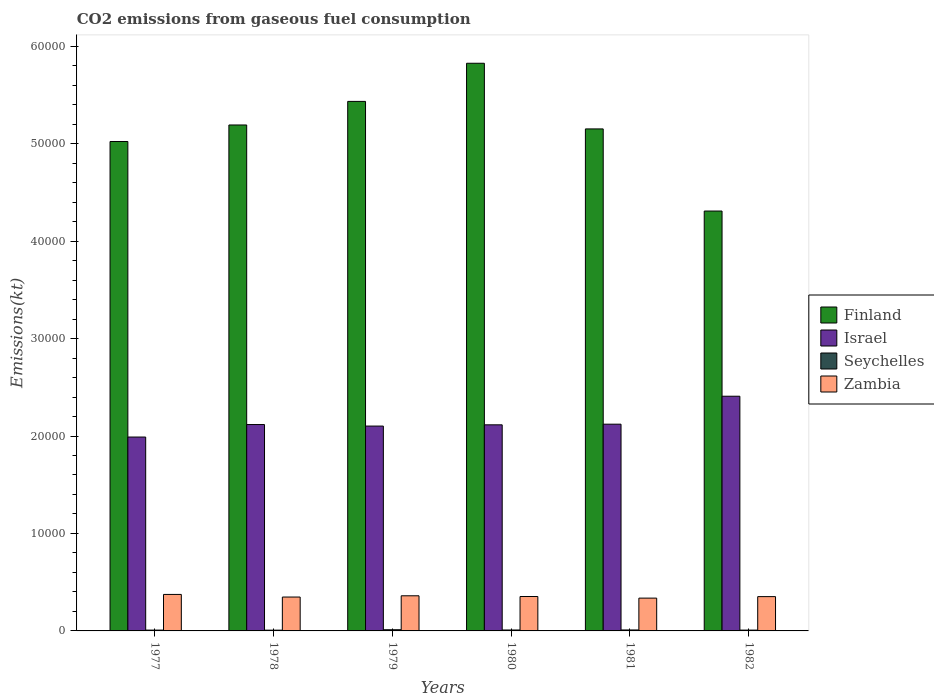Are the number of bars per tick equal to the number of legend labels?
Offer a very short reply. Yes. Are the number of bars on each tick of the X-axis equal?
Offer a terse response. Yes. How many bars are there on the 5th tick from the left?
Keep it short and to the point. 4. How many bars are there on the 4th tick from the right?
Provide a succinct answer. 4. What is the amount of CO2 emitted in Seychelles in 1980?
Provide a short and direct response. 95.34. Across all years, what is the maximum amount of CO2 emitted in Seychelles?
Give a very brief answer. 121.01. Across all years, what is the minimum amount of CO2 emitted in Israel?
Give a very brief answer. 1.99e+04. What is the total amount of CO2 emitted in Seychelles in the graph?
Offer a terse response. 561.05. What is the difference between the amount of CO2 emitted in Seychelles in 1978 and that in 1982?
Provide a succinct answer. -7.33. What is the difference between the amount of CO2 emitted in Finland in 1981 and the amount of CO2 emitted in Zambia in 1982?
Your response must be concise. 4.80e+04. What is the average amount of CO2 emitted in Seychelles per year?
Your response must be concise. 93.51. In the year 1979, what is the difference between the amount of CO2 emitted in Finland and amount of CO2 emitted in Seychelles?
Provide a succinct answer. 5.42e+04. What is the ratio of the amount of CO2 emitted in Zambia in 1979 to that in 1981?
Your answer should be very brief. 1.07. Is the difference between the amount of CO2 emitted in Finland in 1977 and 1980 greater than the difference between the amount of CO2 emitted in Seychelles in 1977 and 1980?
Keep it short and to the point. No. What is the difference between the highest and the second highest amount of CO2 emitted in Zambia?
Ensure brevity in your answer.  139.35. What is the difference between the highest and the lowest amount of CO2 emitted in Israel?
Provide a succinct answer. 4187.71. In how many years, is the amount of CO2 emitted in Israel greater than the average amount of CO2 emitted in Israel taken over all years?
Ensure brevity in your answer.  1. Is the sum of the amount of CO2 emitted in Israel in 1980 and 1981 greater than the maximum amount of CO2 emitted in Zambia across all years?
Offer a terse response. Yes. Is it the case that in every year, the sum of the amount of CO2 emitted in Zambia and amount of CO2 emitted in Finland is greater than the sum of amount of CO2 emitted in Seychelles and amount of CO2 emitted in Israel?
Ensure brevity in your answer.  Yes. What does the 2nd bar from the right in 1982 represents?
Ensure brevity in your answer.  Seychelles. How many bars are there?
Keep it short and to the point. 24. Are all the bars in the graph horizontal?
Provide a succinct answer. No. How many years are there in the graph?
Give a very brief answer. 6. Are the values on the major ticks of Y-axis written in scientific E-notation?
Ensure brevity in your answer.  No. Does the graph contain any zero values?
Your answer should be very brief. No. Does the graph contain grids?
Offer a terse response. No. What is the title of the graph?
Offer a terse response. CO2 emissions from gaseous fuel consumption. Does "Paraguay" appear as one of the legend labels in the graph?
Offer a very short reply. No. What is the label or title of the Y-axis?
Ensure brevity in your answer.  Emissions(kt). What is the Emissions(kt) of Finland in 1977?
Offer a terse response. 5.02e+04. What is the Emissions(kt) of Israel in 1977?
Your answer should be compact. 1.99e+04. What is the Emissions(kt) of Seychelles in 1977?
Your answer should be compact. 84.34. What is the Emissions(kt) of Zambia in 1977?
Provide a short and direct response. 3744.01. What is the Emissions(kt) in Finland in 1978?
Give a very brief answer. 5.19e+04. What is the Emissions(kt) in Israel in 1978?
Provide a short and direct response. 2.12e+04. What is the Emissions(kt) in Seychelles in 1978?
Your response must be concise. 77.01. What is the Emissions(kt) in Zambia in 1978?
Ensure brevity in your answer.  3476.32. What is the Emissions(kt) of Finland in 1979?
Your answer should be very brief. 5.43e+04. What is the Emissions(kt) of Israel in 1979?
Keep it short and to the point. 2.10e+04. What is the Emissions(kt) in Seychelles in 1979?
Offer a very short reply. 121.01. What is the Emissions(kt) of Zambia in 1979?
Give a very brief answer. 3604.66. What is the Emissions(kt) in Finland in 1980?
Give a very brief answer. 5.82e+04. What is the Emissions(kt) in Israel in 1980?
Your answer should be compact. 2.11e+04. What is the Emissions(kt) of Seychelles in 1980?
Offer a terse response. 95.34. What is the Emissions(kt) in Zambia in 1980?
Ensure brevity in your answer.  3531.32. What is the Emissions(kt) of Finland in 1981?
Your answer should be very brief. 5.15e+04. What is the Emissions(kt) of Israel in 1981?
Provide a succinct answer. 2.12e+04. What is the Emissions(kt) in Seychelles in 1981?
Ensure brevity in your answer.  99.01. What is the Emissions(kt) of Zambia in 1981?
Give a very brief answer. 3366.31. What is the Emissions(kt) of Finland in 1982?
Your answer should be compact. 4.31e+04. What is the Emissions(kt) of Israel in 1982?
Provide a short and direct response. 2.41e+04. What is the Emissions(kt) in Seychelles in 1982?
Offer a terse response. 84.34. What is the Emissions(kt) in Zambia in 1982?
Ensure brevity in your answer.  3520.32. Across all years, what is the maximum Emissions(kt) of Finland?
Your answer should be very brief. 5.82e+04. Across all years, what is the maximum Emissions(kt) of Israel?
Your answer should be compact. 2.41e+04. Across all years, what is the maximum Emissions(kt) of Seychelles?
Keep it short and to the point. 121.01. Across all years, what is the maximum Emissions(kt) in Zambia?
Make the answer very short. 3744.01. Across all years, what is the minimum Emissions(kt) of Finland?
Your answer should be very brief. 4.31e+04. Across all years, what is the minimum Emissions(kt) in Israel?
Your answer should be very brief. 1.99e+04. Across all years, what is the minimum Emissions(kt) of Seychelles?
Offer a very short reply. 77.01. Across all years, what is the minimum Emissions(kt) of Zambia?
Your response must be concise. 3366.31. What is the total Emissions(kt) in Finland in the graph?
Provide a succinct answer. 3.09e+05. What is the total Emissions(kt) in Israel in the graph?
Make the answer very short. 1.29e+05. What is the total Emissions(kt) in Seychelles in the graph?
Offer a terse response. 561.05. What is the total Emissions(kt) of Zambia in the graph?
Keep it short and to the point. 2.12e+04. What is the difference between the Emissions(kt) in Finland in 1977 and that in 1978?
Your response must be concise. -1694.15. What is the difference between the Emissions(kt) of Israel in 1977 and that in 1978?
Provide a short and direct response. -1283.45. What is the difference between the Emissions(kt) of Seychelles in 1977 and that in 1978?
Provide a short and direct response. 7.33. What is the difference between the Emissions(kt) in Zambia in 1977 and that in 1978?
Give a very brief answer. 267.69. What is the difference between the Emissions(kt) in Finland in 1977 and that in 1979?
Your answer should be very brief. -4114.37. What is the difference between the Emissions(kt) in Israel in 1977 and that in 1979?
Ensure brevity in your answer.  -1125.77. What is the difference between the Emissions(kt) of Seychelles in 1977 and that in 1979?
Provide a short and direct response. -36.67. What is the difference between the Emissions(kt) of Zambia in 1977 and that in 1979?
Provide a succinct answer. 139.35. What is the difference between the Emissions(kt) in Finland in 1977 and that in 1980?
Provide a short and direct response. -8027.06. What is the difference between the Emissions(kt) in Israel in 1977 and that in 1980?
Keep it short and to the point. -1254.11. What is the difference between the Emissions(kt) in Seychelles in 1977 and that in 1980?
Your response must be concise. -11. What is the difference between the Emissions(kt) in Zambia in 1977 and that in 1980?
Provide a succinct answer. 212.69. What is the difference between the Emissions(kt) of Finland in 1977 and that in 1981?
Provide a short and direct response. -1290.78. What is the difference between the Emissions(kt) of Israel in 1977 and that in 1981?
Provide a short and direct response. -1320.12. What is the difference between the Emissions(kt) of Seychelles in 1977 and that in 1981?
Your response must be concise. -14.67. What is the difference between the Emissions(kt) of Zambia in 1977 and that in 1981?
Your answer should be compact. 377.7. What is the difference between the Emissions(kt) in Finland in 1977 and that in 1982?
Give a very brief answer. 7135.98. What is the difference between the Emissions(kt) in Israel in 1977 and that in 1982?
Provide a succinct answer. -4187.71. What is the difference between the Emissions(kt) of Seychelles in 1977 and that in 1982?
Your response must be concise. 0. What is the difference between the Emissions(kt) in Zambia in 1977 and that in 1982?
Give a very brief answer. 223.69. What is the difference between the Emissions(kt) in Finland in 1978 and that in 1979?
Your answer should be compact. -2420.22. What is the difference between the Emissions(kt) of Israel in 1978 and that in 1979?
Keep it short and to the point. 157.68. What is the difference between the Emissions(kt) of Seychelles in 1978 and that in 1979?
Provide a succinct answer. -44. What is the difference between the Emissions(kt) of Zambia in 1978 and that in 1979?
Provide a short and direct response. -128.34. What is the difference between the Emissions(kt) of Finland in 1978 and that in 1980?
Keep it short and to the point. -6332.91. What is the difference between the Emissions(kt) of Israel in 1978 and that in 1980?
Ensure brevity in your answer.  29.34. What is the difference between the Emissions(kt) of Seychelles in 1978 and that in 1980?
Provide a short and direct response. -18.34. What is the difference between the Emissions(kt) in Zambia in 1978 and that in 1980?
Provide a succinct answer. -55.01. What is the difference between the Emissions(kt) in Finland in 1978 and that in 1981?
Make the answer very short. 403.37. What is the difference between the Emissions(kt) of Israel in 1978 and that in 1981?
Give a very brief answer. -36.67. What is the difference between the Emissions(kt) in Seychelles in 1978 and that in 1981?
Offer a very short reply. -22. What is the difference between the Emissions(kt) in Zambia in 1978 and that in 1981?
Offer a very short reply. 110.01. What is the difference between the Emissions(kt) of Finland in 1978 and that in 1982?
Your response must be concise. 8830.14. What is the difference between the Emissions(kt) of Israel in 1978 and that in 1982?
Your response must be concise. -2904.26. What is the difference between the Emissions(kt) of Seychelles in 1978 and that in 1982?
Make the answer very short. -7.33. What is the difference between the Emissions(kt) in Zambia in 1978 and that in 1982?
Provide a short and direct response. -44. What is the difference between the Emissions(kt) of Finland in 1979 and that in 1980?
Keep it short and to the point. -3912.69. What is the difference between the Emissions(kt) of Israel in 1979 and that in 1980?
Provide a succinct answer. -128.34. What is the difference between the Emissions(kt) of Seychelles in 1979 and that in 1980?
Provide a succinct answer. 25.67. What is the difference between the Emissions(kt) of Zambia in 1979 and that in 1980?
Your answer should be very brief. 73.34. What is the difference between the Emissions(kt) in Finland in 1979 and that in 1981?
Offer a very short reply. 2823.59. What is the difference between the Emissions(kt) of Israel in 1979 and that in 1981?
Ensure brevity in your answer.  -194.35. What is the difference between the Emissions(kt) in Seychelles in 1979 and that in 1981?
Give a very brief answer. 22. What is the difference between the Emissions(kt) in Zambia in 1979 and that in 1981?
Offer a very short reply. 238.35. What is the difference between the Emissions(kt) of Finland in 1979 and that in 1982?
Make the answer very short. 1.13e+04. What is the difference between the Emissions(kt) of Israel in 1979 and that in 1982?
Your answer should be very brief. -3061.95. What is the difference between the Emissions(kt) of Seychelles in 1979 and that in 1982?
Provide a succinct answer. 36.67. What is the difference between the Emissions(kt) of Zambia in 1979 and that in 1982?
Offer a terse response. 84.34. What is the difference between the Emissions(kt) in Finland in 1980 and that in 1981?
Ensure brevity in your answer.  6736.28. What is the difference between the Emissions(kt) of Israel in 1980 and that in 1981?
Provide a succinct answer. -66.01. What is the difference between the Emissions(kt) of Seychelles in 1980 and that in 1981?
Ensure brevity in your answer.  -3.67. What is the difference between the Emissions(kt) of Zambia in 1980 and that in 1981?
Make the answer very short. 165.01. What is the difference between the Emissions(kt) of Finland in 1980 and that in 1982?
Your answer should be very brief. 1.52e+04. What is the difference between the Emissions(kt) in Israel in 1980 and that in 1982?
Give a very brief answer. -2933.6. What is the difference between the Emissions(kt) in Seychelles in 1980 and that in 1982?
Provide a short and direct response. 11. What is the difference between the Emissions(kt) of Zambia in 1980 and that in 1982?
Your answer should be very brief. 11. What is the difference between the Emissions(kt) of Finland in 1981 and that in 1982?
Provide a succinct answer. 8426.77. What is the difference between the Emissions(kt) of Israel in 1981 and that in 1982?
Provide a short and direct response. -2867.59. What is the difference between the Emissions(kt) of Seychelles in 1981 and that in 1982?
Keep it short and to the point. 14.67. What is the difference between the Emissions(kt) of Zambia in 1981 and that in 1982?
Your response must be concise. -154.01. What is the difference between the Emissions(kt) in Finland in 1977 and the Emissions(kt) in Israel in 1978?
Your answer should be very brief. 2.90e+04. What is the difference between the Emissions(kt) of Finland in 1977 and the Emissions(kt) of Seychelles in 1978?
Make the answer very short. 5.01e+04. What is the difference between the Emissions(kt) of Finland in 1977 and the Emissions(kt) of Zambia in 1978?
Your answer should be compact. 4.67e+04. What is the difference between the Emissions(kt) of Israel in 1977 and the Emissions(kt) of Seychelles in 1978?
Your response must be concise. 1.98e+04. What is the difference between the Emissions(kt) in Israel in 1977 and the Emissions(kt) in Zambia in 1978?
Ensure brevity in your answer.  1.64e+04. What is the difference between the Emissions(kt) in Seychelles in 1977 and the Emissions(kt) in Zambia in 1978?
Offer a terse response. -3391.97. What is the difference between the Emissions(kt) in Finland in 1977 and the Emissions(kt) in Israel in 1979?
Keep it short and to the point. 2.92e+04. What is the difference between the Emissions(kt) of Finland in 1977 and the Emissions(kt) of Seychelles in 1979?
Make the answer very short. 5.01e+04. What is the difference between the Emissions(kt) in Finland in 1977 and the Emissions(kt) in Zambia in 1979?
Your response must be concise. 4.66e+04. What is the difference between the Emissions(kt) in Israel in 1977 and the Emissions(kt) in Seychelles in 1979?
Your response must be concise. 1.98e+04. What is the difference between the Emissions(kt) in Israel in 1977 and the Emissions(kt) in Zambia in 1979?
Ensure brevity in your answer.  1.63e+04. What is the difference between the Emissions(kt) of Seychelles in 1977 and the Emissions(kt) of Zambia in 1979?
Offer a very short reply. -3520.32. What is the difference between the Emissions(kt) in Finland in 1977 and the Emissions(kt) in Israel in 1980?
Offer a terse response. 2.91e+04. What is the difference between the Emissions(kt) of Finland in 1977 and the Emissions(kt) of Seychelles in 1980?
Provide a short and direct response. 5.01e+04. What is the difference between the Emissions(kt) in Finland in 1977 and the Emissions(kt) in Zambia in 1980?
Provide a succinct answer. 4.67e+04. What is the difference between the Emissions(kt) in Israel in 1977 and the Emissions(kt) in Seychelles in 1980?
Your response must be concise. 1.98e+04. What is the difference between the Emissions(kt) in Israel in 1977 and the Emissions(kt) in Zambia in 1980?
Ensure brevity in your answer.  1.64e+04. What is the difference between the Emissions(kt) of Seychelles in 1977 and the Emissions(kt) of Zambia in 1980?
Give a very brief answer. -3446.98. What is the difference between the Emissions(kt) of Finland in 1977 and the Emissions(kt) of Israel in 1981?
Your response must be concise. 2.90e+04. What is the difference between the Emissions(kt) in Finland in 1977 and the Emissions(kt) in Seychelles in 1981?
Keep it short and to the point. 5.01e+04. What is the difference between the Emissions(kt) in Finland in 1977 and the Emissions(kt) in Zambia in 1981?
Offer a terse response. 4.69e+04. What is the difference between the Emissions(kt) of Israel in 1977 and the Emissions(kt) of Seychelles in 1981?
Give a very brief answer. 1.98e+04. What is the difference between the Emissions(kt) in Israel in 1977 and the Emissions(kt) in Zambia in 1981?
Your response must be concise. 1.65e+04. What is the difference between the Emissions(kt) of Seychelles in 1977 and the Emissions(kt) of Zambia in 1981?
Ensure brevity in your answer.  -3281.97. What is the difference between the Emissions(kt) in Finland in 1977 and the Emissions(kt) in Israel in 1982?
Provide a succinct answer. 2.61e+04. What is the difference between the Emissions(kt) in Finland in 1977 and the Emissions(kt) in Seychelles in 1982?
Offer a very short reply. 5.01e+04. What is the difference between the Emissions(kt) in Finland in 1977 and the Emissions(kt) in Zambia in 1982?
Offer a very short reply. 4.67e+04. What is the difference between the Emissions(kt) in Israel in 1977 and the Emissions(kt) in Seychelles in 1982?
Your answer should be very brief. 1.98e+04. What is the difference between the Emissions(kt) of Israel in 1977 and the Emissions(kt) of Zambia in 1982?
Give a very brief answer. 1.64e+04. What is the difference between the Emissions(kt) of Seychelles in 1977 and the Emissions(kt) of Zambia in 1982?
Ensure brevity in your answer.  -3435.98. What is the difference between the Emissions(kt) of Finland in 1978 and the Emissions(kt) of Israel in 1979?
Your response must be concise. 3.09e+04. What is the difference between the Emissions(kt) in Finland in 1978 and the Emissions(kt) in Seychelles in 1979?
Offer a very short reply. 5.18e+04. What is the difference between the Emissions(kt) of Finland in 1978 and the Emissions(kt) of Zambia in 1979?
Provide a succinct answer. 4.83e+04. What is the difference between the Emissions(kt) in Israel in 1978 and the Emissions(kt) in Seychelles in 1979?
Give a very brief answer. 2.11e+04. What is the difference between the Emissions(kt) in Israel in 1978 and the Emissions(kt) in Zambia in 1979?
Offer a very short reply. 1.76e+04. What is the difference between the Emissions(kt) of Seychelles in 1978 and the Emissions(kt) of Zambia in 1979?
Your response must be concise. -3527.65. What is the difference between the Emissions(kt) of Finland in 1978 and the Emissions(kt) of Israel in 1980?
Your answer should be very brief. 3.08e+04. What is the difference between the Emissions(kt) in Finland in 1978 and the Emissions(kt) in Seychelles in 1980?
Give a very brief answer. 5.18e+04. What is the difference between the Emissions(kt) of Finland in 1978 and the Emissions(kt) of Zambia in 1980?
Your response must be concise. 4.84e+04. What is the difference between the Emissions(kt) in Israel in 1978 and the Emissions(kt) in Seychelles in 1980?
Your response must be concise. 2.11e+04. What is the difference between the Emissions(kt) in Israel in 1978 and the Emissions(kt) in Zambia in 1980?
Provide a succinct answer. 1.76e+04. What is the difference between the Emissions(kt) of Seychelles in 1978 and the Emissions(kt) of Zambia in 1980?
Offer a very short reply. -3454.31. What is the difference between the Emissions(kt) in Finland in 1978 and the Emissions(kt) in Israel in 1981?
Provide a short and direct response. 3.07e+04. What is the difference between the Emissions(kt) of Finland in 1978 and the Emissions(kt) of Seychelles in 1981?
Offer a very short reply. 5.18e+04. What is the difference between the Emissions(kt) in Finland in 1978 and the Emissions(kt) in Zambia in 1981?
Give a very brief answer. 4.85e+04. What is the difference between the Emissions(kt) of Israel in 1978 and the Emissions(kt) of Seychelles in 1981?
Your response must be concise. 2.11e+04. What is the difference between the Emissions(kt) in Israel in 1978 and the Emissions(kt) in Zambia in 1981?
Provide a short and direct response. 1.78e+04. What is the difference between the Emissions(kt) of Seychelles in 1978 and the Emissions(kt) of Zambia in 1981?
Keep it short and to the point. -3289.3. What is the difference between the Emissions(kt) of Finland in 1978 and the Emissions(kt) of Israel in 1982?
Ensure brevity in your answer.  2.78e+04. What is the difference between the Emissions(kt) of Finland in 1978 and the Emissions(kt) of Seychelles in 1982?
Your answer should be compact. 5.18e+04. What is the difference between the Emissions(kt) in Finland in 1978 and the Emissions(kt) in Zambia in 1982?
Offer a terse response. 4.84e+04. What is the difference between the Emissions(kt) of Israel in 1978 and the Emissions(kt) of Seychelles in 1982?
Offer a very short reply. 2.11e+04. What is the difference between the Emissions(kt) of Israel in 1978 and the Emissions(kt) of Zambia in 1982?
Offer a very short reply. 1.77e+04. What is the difference between the Emissions(kt) in Seychelles in 1978 and the Emissions(kt) in Zambia in 1982?
Ensure brevity in your answer.  -3443.31. What is the difference between the Emissions(kt) of Finland in 1979 and the Emissions(kt) of Israel in 1980?
Your response must be concise. 3.32e+04. What is the difference between the Emissions(kt) of Finland in 1979 and the Emissions(kt) of Seychelles in 1980?
Offer a terse response. 5.42e+04. What is the difference between the Emissions(kt) of Finland in 1979 and the Emissions(kt) of Zambia in 1980?
Ensure brevity in your answer.  5.08e+04. What is the difference between the Emissions(kt) of Israel in 1979 and the Emissions(kt) of Seychelles in 1980?
Make the answer very short. 2.09e+04. What is the difference between the Emissions(kt) in Israel in 1979 and the Emissions(kt) in Zambia in 1980?
Make the answer very short. 1.75e+04. What is the difference between the Emissions(kt) in Seychelles in 1979 and the Emissions(kt) in Zambia in 1980?
Your response must be concise. -3410.31. What is the difference between the Emissions(kt) in Finland in 1979 and the Emissions(kt) in Israel in 1981?
Your answer should be compact. 3.31e+04. What is the difference between the Emissions(kt) in Finland in 1979 and the Emissions(kt) in Seychelles in 1981?
Offer a terse response. 5.42e+04. What is the difference between the Emissions(kt) of Finland in 1979 and the Emissions(kt) of Zambia in 1981?
Ensure brevity in your answer.  5.10e+04. What is the difference between the Emissions(kt) in Israel in 1979 and the Emissions(kt) in Seychelles in 1981?
Offer a very short reply. 2.09e+04. What is the difference between the Emissions(kt) in Israel in 1979 and the Emissions(kt) in Zambia in 1981?
Your response must be concise. 1.77e+04. What is the difference between the Emissions(kt) in Seychelles in 1979 and the Emissions(kt) in Zambia in 1981?
Keep it short and to the point. -3245.3. What is the difference between the Emissions(kt) in Finland in 1979 and the Emissions(kt) in Israel in 1982?
Keep it short and to the point. 3.03e+04. What is the difference between the Emissions(kt) in Finland in 1979 and the Emissions(kt) in Seychelles in 1982?
Your answer should be very brief. 5.42e+04. What is the difference between the Emissions(kt) in Finland in 1979 and the Emissions(kt) in Zambia in 1982?
Your answer should be very brief. 5.08e+04. What is the difference between the Emissions(kt) of Israel in 1979 and the Emissions(kt) of Seychelles in 1982?
Your answer should be compact. 2.09e+04. What is the difference between the Emissions(kt) of Israel in 1979 and the Emissions(kt) of Zambia in 1982?
Make the answer very short. 1.75e+04. What is the difference between the Emissions(kt) of Seychelles in 1979 and the Emissions(kt) of Zambia in 1982?
Make the answer very short. -3399.31. What is the difference between the Emissions(kt) in Finland in 1980 and the Emissions(kt) in Israel in 1981?
Offer a terse response. 3.70e+04. What is the difference between the Emissions(kt) in Finland in 1980 and the Emissions(kt) in Seychelles in 1981?
Your answer should be compact. 5.81e+04. What is the difference between the Emissions(kt) in Finland in 1980 and the Emissions(kt) in Zambia in 1981?
Your response must be concise. 5.49e+04. What is the difference between the Emissions(kt) of Israel in 1980 and the Emissions(kt) of Seychelles in 1981?
Make the answer very short. 2.10e+04. What is the difference between the Emissions(kt) in Israel in 1980 and the Emissions(kt) in Zambia in 1981?
Keep it short and to the point. 1.78e+04. What is the difference between the Emissions(kt) in Seychelles in 1980 and the Emissions(kt) in Zambia in 1981?
Provide a succinct answer. -3270.96. What is the difference between the Emissions(kt) in Finland in 1980 and the Emissions(kt) in Israel in 1982?
Your response must be concise. 3.42e+04. What is the difference between the Emissions(kt) of Finland in 1980 and the Emissions(kt) of Seychelles in 1982?
Your response must be concise. 5.82e+04. What is the difference between the Emissions(kt) in Finland in 1980 and the Emissions(kt) in Zambia in 1982?
Offer a terse response. 5.47e+04. What is the difference between the Emissions(kt) of Israel in 1980 and the Emissions(kt) of Seychelles in 1982?
Provide a succinct answer. 2.11e+04. What is the difference between the Emissions(kt) in Israel in 1980 and the Emissions(kt) in Zambia in 1982?
Offer a very short reply. 1.76e+04. What is the difference between the Emissions(kt) in Seychelles in 1980 and the Emissions(kt) in Zambia in 1982?
Provide a short and direct response. -3424.98. What is the difference between the Emissions(kt) of Finland in 1981 and the Emissions(kt) of Israel in 1982?
Keep it short and to the point. 2.74e+04. What is the difference between the Emissions(kt) of Finland in 1981 and the Emissions(kt) of Seychelles in 1982?
Your answer should be compact. 5.14e+04. What is the difference between the Emissions(kt) in Finland in 1981 and the Emissions(kt) in Zambia in 1982?
Offer a very short reply. 4.80e+04. What is the difference between the Emissions(kt) of Israel in 1981 and the Emissions(kt) of Seychelles in 1982?
Keep it short and to the point. 2.11e+04. What is the difference between the Emissions(kt) in Israel in 1981 and the Emissions(kt) in Zambia in 1982?
Keep it short and to the point. 1.77e+04. What is the difference between the Emissions(kt) in Seychelles in 1981 and the Emissions(kt) in Zambia in 1982?
Offer a terse response. -3421.31. What is the average Emissions(kt) in Finland per year?
Offer a very short reply. 5.16e+04. What is the average Emissions(kt) of Israel per year?
Ensure brevity in your answer.  2.14e+04. What is the average Emissions(kt) in Seychelles per year?
Your answer should be very brief. 93.51. What is the average Emissions(kt) in Zambia per year?
Provide a succinct answer. 3540.49. In the year 1977, what is the difference between the Emissions(kt) in Finland and Emissions(kt) in Israel?
Your answer should be compact. 3.03e+04. In the year 1977, what is the difference between the Emissions(kt) of Finland and Emissions(kt) of Seychelles?
Make the answer very short. 5.01e+04. In the year 1977, what is the difference between the Emissions(kt) of Finland and Emissions(kt) of Zambia?
Ensure brevity in your answer.  4.65e+04. In the year 1977, what is the difference between the Emissions(kt) of Israel and Emissions(kt) of Seychelles?
Ensure brevity in your answer.  1.98e+04. In the year 1977, what is the difference between the Emissions(kt) in Israel and Emissions(kt) in Zambia?
Offer a terse response. 1.61e+04. In the year 1977, what is the difference between the Emissions(kt) of Seychelles and Emissions(kt) of Zambia?
Provide a succinct answer. -3659.67. In the year 1978, what is the difference between the Emissions(kt) of Finland and Emissions(kt) of Israel?
Your response must be concise. 3.07e+04. In the year 1978, what is the difference between the Emissions(kt) of Finland and Emissions(kt) of Seychelles?
Your answer should be compact. 5.18e+04. In the year 1978, what is the difference between the Emissions(kt) in Finland and Emissions(kt) in Zambia?
Your response must be concise. 4.84e+04. In the year 1978, what is the difference between the Emissions(kt) in Israel and Emissions(kt) in Seychelles?
Your answer should be very brief. 2.11e+04. In the year 1978, what is the difference between the Emissions(kt) in Israel and Emissions(kt) in Zambia?
Offer a terse response. 1.77e+04. In the year 1978, what is the difference between the Emissions(kt) of Seychelles and Emissions(kt) of Zambia?
Your answer should be very brief. -3399.31. In the year 1979, what is the difference between the Emissions(kt) in Finland and Emissions(kt) in Israel?
Provide a succinct answer. 3.33e+04. In the year 1979, what is the difference between the Emissions(kt) of Finland and Emissions(kt) of Seychelles?
Your answer should be compact. 5.42e+04. In the year 1979, what is the difference between the Emissions(kt) in Finland and Emissions(kt) in Zambia?
Offer a very short reply. 5.07e+04. In the year 1979, what is the difference between the Emissions(kt) of Israel and Emissions(kt) of Seychelles?
Your answer should be very brief. 2.09e+04. In the year 1979, what is the difference between the Emissions(kt) in Israel and Emissions(kt) in Zambia?
Ensure brevity in your answer.  1.74e+04. In the year 1979, what is the difference between the Emissions(kt) of Seychelles and Emissions(kt) of Zambia?
Provide a short and direct response. -3483.65. In the year 1980, what is the difference between the Emissions(kt) in Finland and Emissions(kt) in Israel?
Give a very brief answer. 3.71e+04. In the year 1980, what is the difference between the Emissions(kt) of Finland and Emissions(kt) of Seychelles?
Make the answer very short. 5.82e+04. In the year 1980, what is the difference between the Emissions(kt) in Finland and Emissions(kt) in Zambia?
Provide a short and direct response. 5.47e+04. In the year 1980, what is the difference between the Emissions(kt) of Israel and Emissions(kt) of Seychelles?
Provide a succinct answer. 2.11e+04. In the year 1980, what is the difference between the Emissions(kt) in Israel and Emissions(kt) in Zambia?
Ensure brevity in your answer.  1.76e+04. In the year 1980, what is the difference between the Emissions(kt) of Seychelles and Emissions(kt) of Zambia?
Make the answer very short. -3435.98. In the year 1981, what is the difference between the Emissions(kt) of Finland and Emissions(kt) of Israel?
Ensure brevity in your answer.  3.03e+04. In the year 1981, what is the difference between the Emissions(kt) of Finland and Emissions(kt) of Seychelles?
Give a very brief answer. 5.14e+04. In the year 1981, what is the difference between the Emissions(kt) in Finland and Emissions(kt) in Zambia?
Provide a short and direct response. 4.81e+04. In the year 1981, what is the difference between the Emissions(kt) in Israel and Emissions(kt) in Seychelles?
Ensure brevity in your answer.  2.11e+04. In the year 1981, what is the difference between the Emissions(kt) in Israel and Emissions(kt) in Zambia?
Offer a very short reply. 1.78e+04. In the year 1981, what is the difference between the Emissions(kt) in Seychelles and Emissions(kt) in Zambia?
Your response must be concise. -3267.3. In the year 1982, what is the difference between the Emissions(kt) of Finland and Emissions(kt) of Israel?
Your answer should be very brief. 1.90e+04. In the year 1982, what is the difference between the Emissions(kt) of Finland and Emissions(kt) of Seychelles?
Provide a succinct answer. 4.30e+04. In the year 1982, what is the difference between the Emissions(kt) of Finland and Emissions(kt) of Zambia?
Ensure brevity in your answer.  3.96e+04. In the year 1982, what is the difference between the Emissions(kt) in Israel and Emissions(kt) in Seychelles?
Offer a very short reply. 2.40e+04. In the year 1982, what is the difference between the Emissions(kt) in Israel and Emissions(kt) in Zambia?
Give a very brief answer. 2.06e+04. In the year 1982, what is the difference between the Emissions(kt) of Seychelles and Emissions(kt) of Zambia?
Make the answer very short. -3435.98. What is the ratio of the Emissions(kt) of Finland in 1977 to that in 1978?
Provide a short and direct response. 0.97. What is the ratio of the Emissions(kt) of Israel in 1977 to that in 1978?
Your response must be concise. 0.94. What is the ratio of the Emissions(kt) in Seychelles in 1977 to that in 1978?
Give a very brief answer. 1.1. What is the ratio of the Emissions(kt) in Zambia in 1977 to that in 1978?
Provide a short and direct response. 1.08. What is the ratio of the Emissions(kt) in Finland in 1977 to that in 1979?
Give a very brief answer. 0.92. What is the ratio of the Emissions(kt) in Israel in 1977 to that in 1979?
Keep it short and to the point. 0.95. What is the ratio of the Emissions(kt) of Seychelles in 1977 to that in 1979?
Provide a succinct answer. 0.7. What is the ratio of the Emissions(kt) of Zambia in 1977 to that in 1979?
Your response must be concise. 1.04. What is the ratio of the Emissions(kt) of Finland in 1977 to that in 1980?
Give a very brief answer. 0.86. What is the ratio of the Emissions(kt) of Israel in 1977 to that in 1980?
Offer a terse response. 0.94. What is the ratio of the Emissions(kt) of Seychelles in 1977 to that in 1980?
Keep it short and to the point. 0.88. What is the ratio of the Emissions(kt) in Zambia in 1977 to that in 1980?
Your answer should be very brief. 1.06. What is the ratio of the Emissions(kt) in Finland in 1977 to that in 1981?
Your response must be concise. 0.97. What is the ratio of the Emissions(kt) in Israel in 1977 to that in 1981?
Provide a short and direct response. 0.94. What is the ratio of the Emissions(kt) of Seychelles in 1977 to that in 1981?
Provide a short and direct response. 0.85. What is the ratio of the Emissions(kt) of Zambia in 1977 to that in 1981?
Your response must be concise. 1.11. What is the ratio of the Emissions(kt) of Finland in 1977 to that in 1982?
Your answer should be very brief. 1.17. What is the ratio of the Emissions(kt) in Israel in 1977 to that in 1982?
Ensure brevity in your answer.  0.83. What is the ratio of the Emissions(kt) of Seychelles in 1977 to that in 1982?
Make the answer very short. 1. What is the ratio of the Emissions(kt) of Zambia in 1977 to that in 1982?
Your answer should be very brief. 1.06. What is the ratio of the Emissions(kt) of Finland in 1978 to that in 1979?
Offer a terse response. 0.96. What is the ratio of the Emissions(kt) of Israel in 1978 to that in 1979?
Offer a very short reply. 1.01. What is the ratio of the Emissions(kt) in Seychelles in 1978 to that in 1979?
Offer a terse response. 0.64. What is the ratio of the Emissions(kt) of Zambia in 1978 to that in 1979?
Give a very brief answer. 0.96. What is the ratio of the Emissions(kt) in Finland in 1978 to that in 1980?
Your answer should be compact. 0.89. What is the ratio of the Emissions(kt) of Israel in 1978 to that in 1980?
Give a very brief answer. 1. What is the ratio of the Emissions(kt) in Seychelles in 1978 to that in 1980?
Offer a very short reply. 0.81. What is the ratio of the Emissions(kt) in Zambia in 1978 to that in 1980?
Provide a succinct answer. 0.98. What is the ratio of the Emissions(kt) in Israel in 1978 to that in 1981?
Give a very brief answer. 1. What is the ratio of the Emissions(kt) of Zambia in 1978 to that in 1981?
Your answer should be compact. 1.03. What is the ratio of the Emissions(kt) in Finland in 1978 to that in 1982?
Your answer should be compact. 1.21. What is the ratio of the Emissions(kt) in Israel in 1978 to that in 1982?
Offer a very short reply. 0.88. What is the ratio of the Emissions(kt) in Zambia in 1978 to that in 1982?
Offer a very short reply. 0.99. What is the ratio of the Emissions(kt) of Finland in 1979 to that in 1980?
Your answer should be very brief. 0.93. What is the ratio of the Emissions(kt) in Seychelles in 1979 to that in 1980?
Your response must be concise. 1.27. What is the ratio of the Emissions(kt) of Zambia in 1979 to that in 1980?
Give a very brief answer. 1.02. What is the ratio of the Emissions(kt) of Finland in 1979 to that in 1981?
Your answer should be compact. 1.05. What is the ratio of the Emissions(kt) of Seychelles in 1979 to that in 1981?
Offer a very short reply. 1.22. What is the ratio of the Emissions(kt) in Zambia in 1979 to that in 1981?
Your answer should be very brief. 1.07. What is the ratio of the Emissions(kt) of Finland in 1979 to that in 1982?
Offer a terse response. 1.26. What is the ratio of the Emissions(kt) in Israel in 1979 to that in 1982?
Your answer should be very brief. 0.87. What is the ratio of the Emissions(kt) of Seychelles in 1979 to that in 1982?
Provide a short and direct response. 1.43. What is the ratio of the Emissions(kt) of Finland in 1980 to that in 1981?
Ensure brevity in your answer.  1.13. What is the ratio of the Emissions(kt) of Seychelles in 1980 to that in 1981?
Offer a terse response. 0.96. What is the ratio of the Emissions(kt) of Zambia in 1980 to that in 1981?
Provide a succinct answer. 1.05. What is the ratio of the Emissions(kt) of Finland in 1980 to that in 1982?
Provide a short and direct response. 1.35. What is the ratio of the Emissions(kt) in Israel in 1980 to that in 1982?
Give a very brief answer. 0.88. What is the ratio of the Emissions(kt) of Seychelles in 1980 to that in 1982?
Provide a short and direct response. 1.13. What is the ratio of the Emissions(kt) of Zambia in 1980 to that in 1982?
Keep it short and to the point. 1. What is the ratio of the Emissions(kt) of Finland in 1981 to that in 1982?
Your response must be concise. 1.2. What is the ratio of the Emissions(kt) in Israel in 1981 to that in 1982?
Offer a terse response. 0.88. What is the ratio of the Emissions(kt) of Seychelles in 1981 to that in 1982?
Offer a very short reply. 1.17. What is the ratio of the Emissions(kt) of Zambia in 1981 to that in 1982?
Ensure brevity in your answer.  0.96. What is the difference between the highest and the second highest Emissions(kt) of Finland?
Make the answer very short. 3912.69. What is the difference between the highest and the second highest Emissions(kt) of Israel?
Offer a very short reply. 2867.59. What is the difference between the highest and the second highest Emissions(kt) in Seychelles?
Give a very brief answer. 22. What is the difference between the highest and the second highest Emissions(kt) of Zambia?
Provide a succinct answer. 139.35. What is the difference between the highest and the lowest Emissions(kt) of Finland?
Provide a short and direct response. 1.52e+04. What is the difference between the highest and the lowest Emissions(kt) of Israel?
Keep it short and to the point. 4187.71. What is the difference between the highest and the lowest Emissions(kt) in Seychelles?
Your answer should be very brief. 44. What is the difference between the highest and the lowest Emissions(kt) of Zambia?
Make the answer very short. 377.7. 